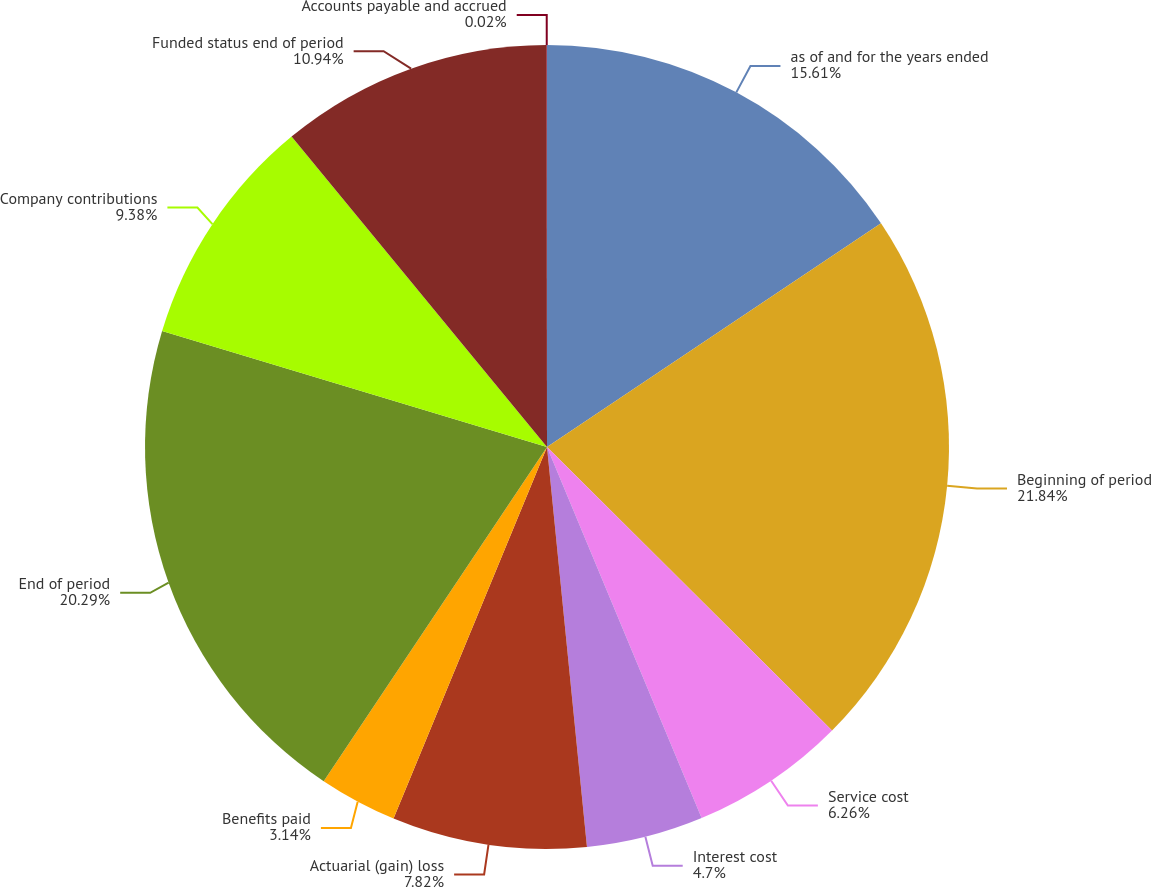Convert chart to OTSL. <chart><loc_0><loc_0><loc_500><loc_500><pie_chart><fcel>as of and for the years ended<fcel>Beginning of period<fcel>Service cost<fcel>Interest cost<fcel>Actuarial (gain) loss<fcel>Benefits paid<fcel>End of period<fcel>Company contributions<fcel>Funded status end of period<fcel>Accounts payable and accrued<nl><fcel>15.61%<fcel>21.85%<fcel>6.26%<fcel>4.7%<fcel>7.82%<fcel>3.14%<fcel>20.29%<fcel>9.38%<fcel>10.94%<fcel>0.02%<nl></chart> 